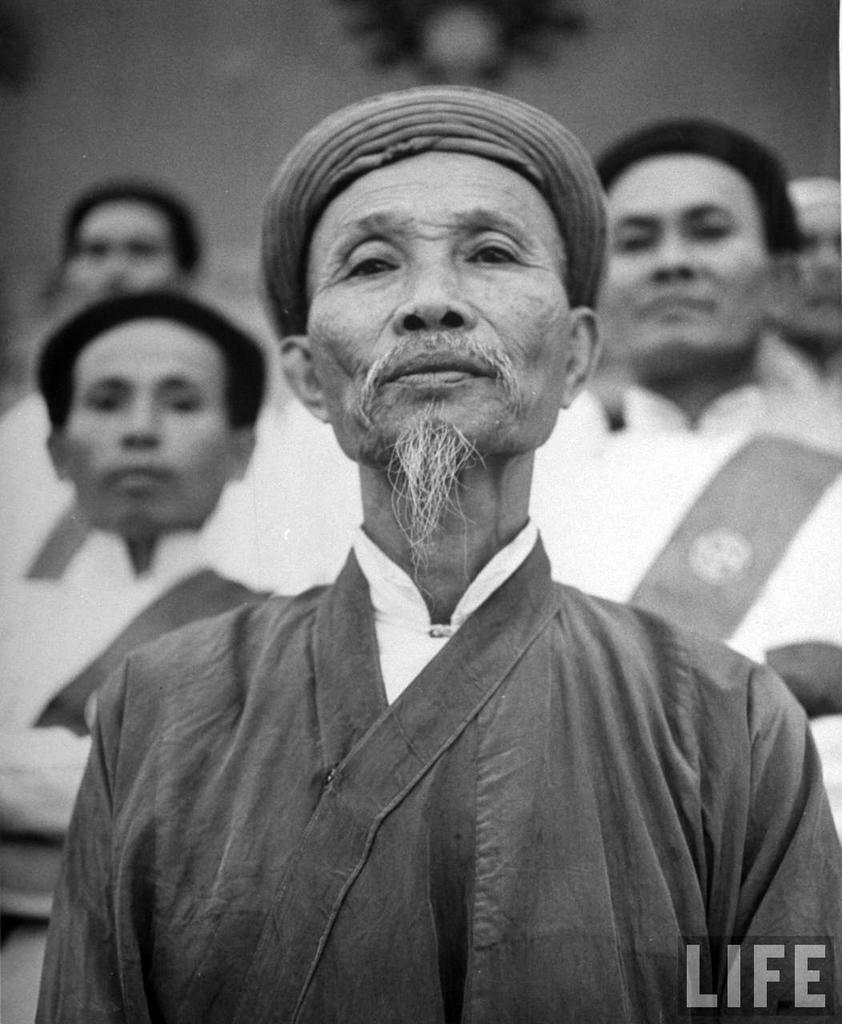Could you give a brief overview of what you see in this image? This is a black and white image. Here I can see few men looking at the picture. The background is blurred. In the bottom right there is some text. 